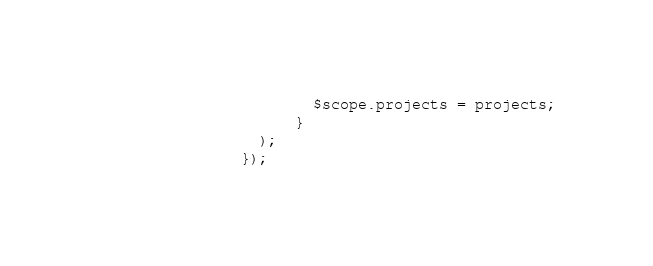<code> <loc_0><loc_0><loc_500><loc_500><_JavaScript_>                        $scope.projects = projects;
                      }
                  );
                });
</code> 